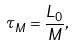<formula> <loc_0><loc_0><loc_500><loc_500>\tau _ { M } = \frac { L _ { 0 } } { M } ,</formula> 